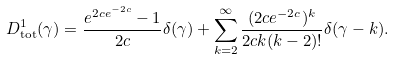<formula> <loc_0><loc_0><loc_500><loc_500>D _ { \text {tot} } ^ { 1 } ( \gamma ) = \frac { e ^ { 2 c e ^ { - 2 c } } - 1 } { 2 c } \delta ( \gamma ) + \sum _ { k = 2 } ^ { \infty } \frac { ( 2 c e ^ { - 2 c } ) ^ { k } } { 2 c k ( k - 2 ) ! } \delta ( \gamma - k ) .</formula> 